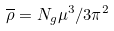<formula> <loc_0><loc_0><loc_500><loc_500>\overline { \rho } = N _ { g } \mu ^ { 3 } / 3 \pi ^ { 2 }</formula> 